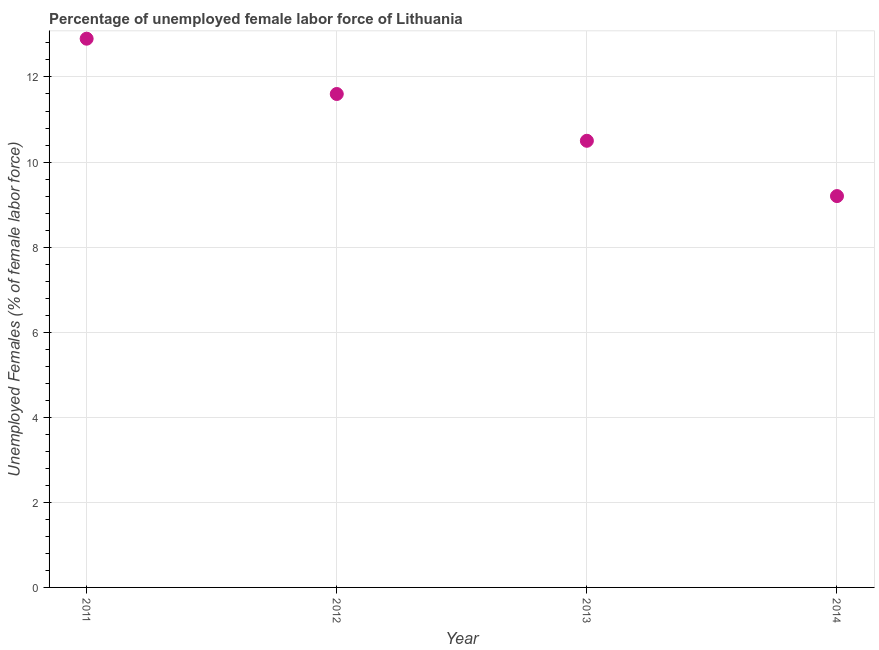Across all years, what is the maximum total unemployed female labour force?
Give a very brief answer. 12.9. Across all years, what is the minimum total unemployed female labour force?
Your answer should be compact. 9.2. In which year was the total unemployed female labour force maximum?
Ensure brevity in your answer.  2011. What is the sum of the total unemployed female labour force?
Give a very brief answer. 44.2. What is the difference between the total unemployed female labour force in 2013 and 2014?
Give a very brief answer. 1.3. What is the average total unemployed female labour force per year?
Keep it short and to the point. 11.05. What is the median total unemployed female labour force?
Ensure brevity in your answer.  11.05. In how many years, is the total unemployed female labour force greater than 4 %?
Your answer should be very brief. 4. Do a majority of the years between 2013 and 2014 (inclusive) have total unemployed female labour force greater than 10.4 %?
Give a very brief answer. No. What is the ratio of the total unemployed female labour force in 2011 to that in 2013?
Your response must be concise. 1.23. Is the total unemployed female labour force in 2013 less than that in 2014?
Your answer should be compact. No. What is the difference between the highest and the second highest total unemployed female labour force?
Provide a short and direct response. 1.3. What is the difference between the highest and the lowest total unemployed female labour force?
Offer a terse response. 3.7. How many years are there in the graph?
Provide a succinct answer. 4. What is the difference between two consecutive major ticks on the Y-axis?
Your response must be concise. 2. Does the graph contain grids?
Offer a terse response. Yes. What is the title of the graph?
Your answer should be very brief. Percentage of unemployed female labor force of Lithuania. What is the label or title of the X-axis?
Your answer should be very brief. Year. What is the label or title of the Y-axis?
Give a very brief answer. Unemployed Females (% of female labor force). What is the Unemployed Females (% of female labor force) in 2011?
Your answer should be very brief. 12.9. What is the Unemployed Females (% of female labor force) in 2012?
Your response must be concise. 11.6. What is the Unemployed Females (% of female labor force) in 2013?
Your response must be concise. 10.5. What is the Unemployed Females (% of female labor force) in 2014?
Your answer should be very brief. 9.2. What is the difference between the Unemployed Females (% of female labor force) in 2011 and 2014?
Ensure brevity in your answer.  3.7. What is the difference between the Unemployed Females (% of female labor force) in 2012 and 2013?
Give a very brief answer. 1.1. What is the difference between the Unemployed Females (% of female labor force) in 2012 and 2014?
Provide a short and direct response. 2.4. What is the difference between the Unemployed Females (% of female labor force) in 2013 and 2014?
Provide a short and direct response. 1.3. What is the ratio of the Unemployed Females (% of female labor force) in 2011 to that in 2012?
Your response must be concise. 1.11. What is the ratio of the Unemployed Females (% of female labor force) in 2011 to that in 2013?
Your answer should be very brief. 1.23. What is the ratio of the Unemployed Females (% of female labor force) in 2011 to that in 2014?
Keep it short and to the point. 1.4. What is the ratio of the Unemployed Females (% of female labor force) in 2012 to that in 2013?
Provide a short and direct response. 1.1. What is the ratio of the Unemployed Females (% of female labor force) in 2012 to that in 2014?
Your response must be concise. 1.26. What is the ratio of the Unemployed Females (% of female labor force) in 2013 to that in 2014?
Your answer should be very brief. 1.14. 